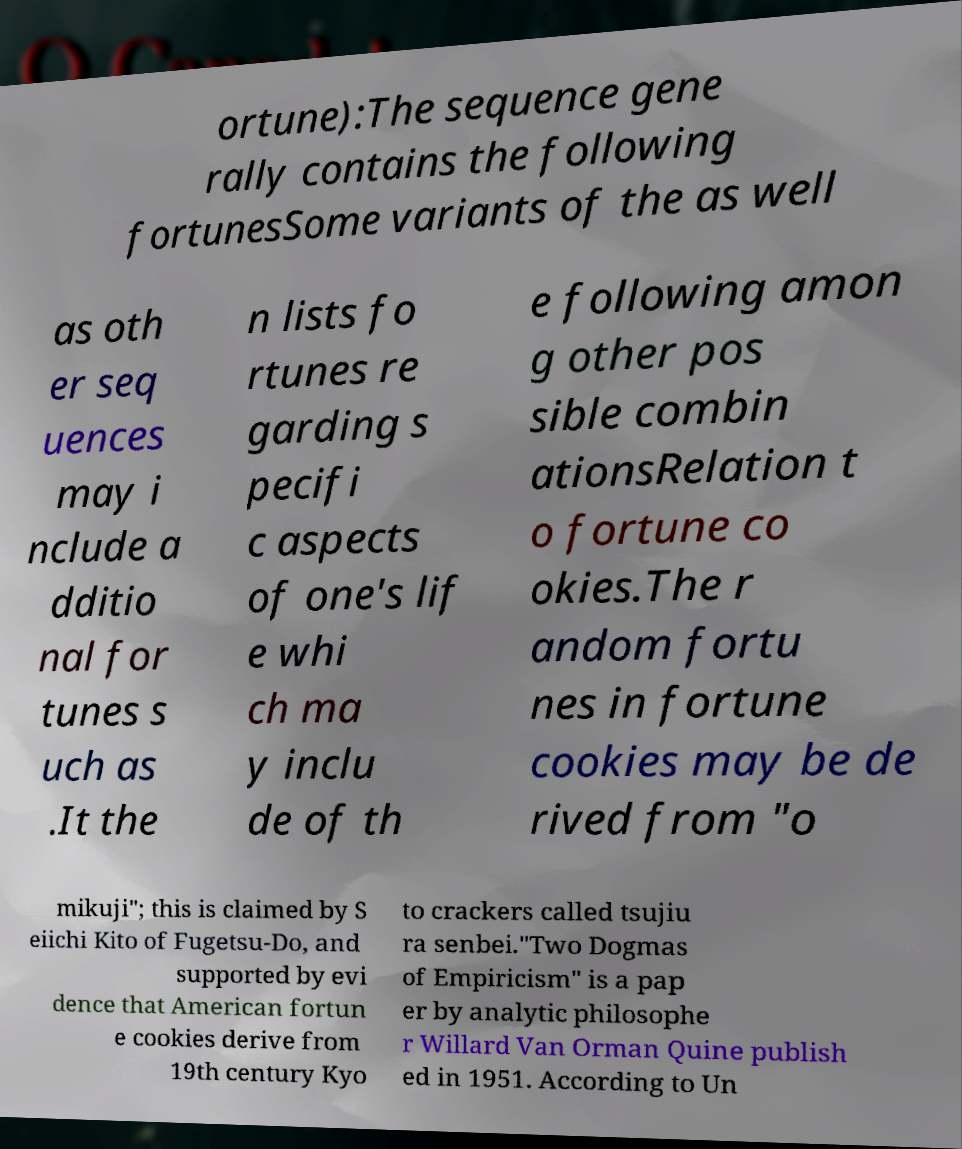Please identify and transcribe the text found in this image. ortune):The sequence gene rally contains the following fortunesSome variants of the as well as oth er seq uences may i nclude a dditio nal for tunes s uch as .It the n lists fo rtunes re garding s pecifi c aspects of one's lif e whi ch ma y inclu de of th e following amon g other pos sible combin ationsRelation t o fortune co okies.The r andom fortu nes in fortune cookies may be de rived from "o mikuji"; this is claimed by S eiichi Kito of Fugetsu-Do, and supported by evi dence that American fortun e cookies derive from 19th century Kyo to crackers called tsujiu ra senbei."Two Dogmas of Empiricism" is a pap er by analytic philosophe r Willard Van Orman Quine publish ed in 1951. According to Un 